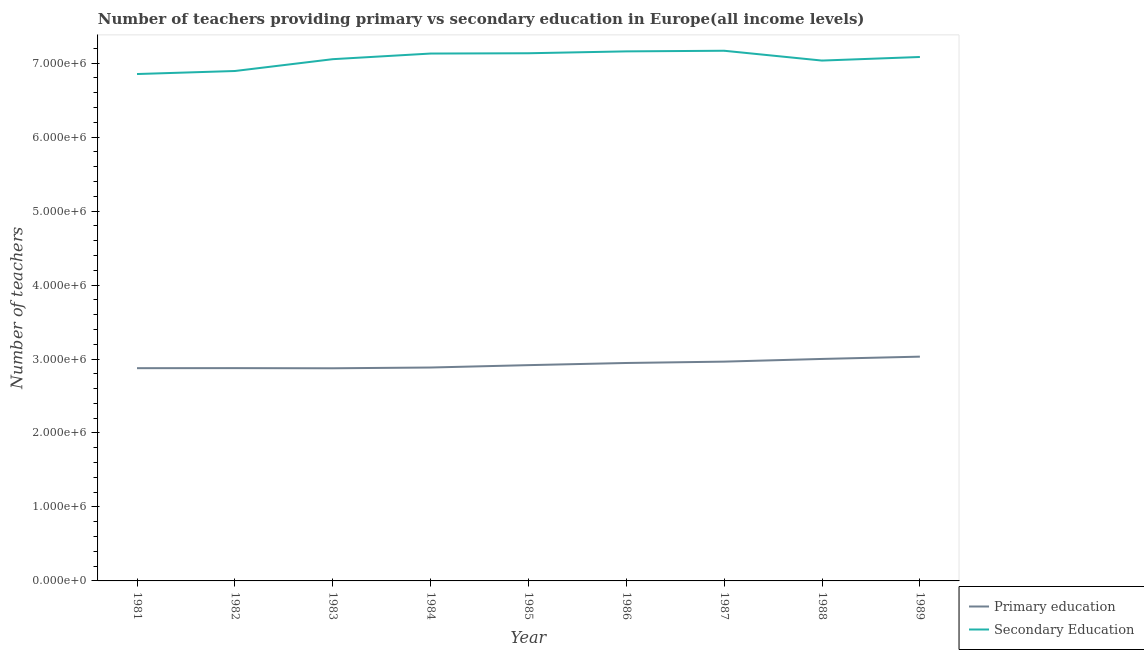What is the number of secondary teachers in 1985?
Offer a terse response. 7.13e+06. Across all years, what is the maximum number of secondary teachers?
Keep it short and to the point. 7.17e+06. Across all years, what is the minimum number of secondary teachers?
Your answer should be compact. 6.85e+06. In which year was the number of secondary teachers maximum?
Provide a short and direct response. 1987. In which year was the number of primary teachers minimum?
Offer a very short reply. 1983. What is the total number of secondary teachers in the graph?
Give a very brief answer. 6.35e+07. What is the difference between the number of secondary teachers in 1981 and that in 1986?
Make the answer very short. -3.06e+05. What is the difference between the number of secondary teachers in 1983 and the number of primary teachers in 1982?
Offer a very short reply. 4.18e+06. What is the average number of secondary teachers per year?
Your answer should be very brief. 7.06e+06. In the year 1985, what is the difference between the number of secondary teachers and number of primary teachers?
Your answer should be very brief. 4.22e+06. What is the ratio of the number of secondary teachers in 1987 to that in 1989?
Your response must be concise. 1.01. Is the number of primary teachers in 1985 less than that in 1989?
Offer a terse response. Yes. What is the difference between the highest and the second highest number of primary teachers?
Your answer should be very brief. 3.12e+04. What is the difference between the highest and the lowest number of primary teachers?
Offer a terse response. 1.57e+05. Does the number of primary teachers monotonically increase over the years?
Your response must be concise. No. Are the values on the major ticks of Y-axis written in scientific E-notation?
Your answer should be very brief. Yes. Does the graph contain any zero values?
Your answer should be very brief. No. Does the graph contain grids?
Provide a succinct answer. No. How many legend labels are there?
Your response must be concise. 2. How are the legend labels stacked?
Keep it short and to the point. Vertical. What is the title of the graph?
Your response must be concise. Number of teachers providing primary vs secondary education in Europe(all income levels). Does "Banks" appear as one of the legend labels in the graph?
Provide a short and direct response. No. What is the label or title of the X-axis?
Provide a succinct answer. Year. What is the label or title of the Y-axis?
Offer a terse response. Number of teachers. What is the Number of teachers in Primary education in 1981?
Offer a terse response. 2.88e+06. What is the Number of teachers of Secondary Education in 1981?
Your answer should be compact. 6.85e+06. What is the Number of teachers of Primary education in 1982?
Ensure brevity in your answer.  2.88e+06. What is the Number of teachers in Secondary Education in 1982?
Offer a very short reply. 6.89e+06. What is the Number of teachers of Primary education in 1983?
Your response must be concise. 2.87e+06. What is the Number of teachers in Secondary Education in 1983?
Offer a terse response. 7.05e+06. What is the Number of teachers of Primary education in 1984?
Offer a very short reply. 2.88e+06. What is the Number of teachers in Secondary Education in 1984?
Provide a succinct answer. 7.13e+06. What is the Number of teachers in Primary education in 1985?
Your answer should be very brief. 2.92e+06. What is the Number of teachers of Secondary Education in 1985?
Provide a short and direct response. 7.13e+06. What is the Number of teachers of Primary education in 1986?
Provide a short and direct response. 2.95e+06. What is the Number of teachers in Secondary Education in 1986?
Your answer should be compact. 7.16e+06. What is the Number of teachers in Primary education in 1987?
Provide a short and direct response. 2.96e+06. What is the Number of teachers in Secondary Education in 1987?
Provide a short and direct response. 7.17e+06. What is the Number of teachers of Primary education in 1988?
Provide a short and direct response. 3.00e+06. What is the Number of teachers of Secondary Education in 1988?
Give a very brief answer. 7.03e+06. What is the Number of teachers in Primary education in 1989?
Offer a terse response. 3.03e+06. What is the Number of teachers of Secondary Education in 1989?
Your answer should be compact. 7.08e+06. Across all years, what is the maximum Number of teachers of Primary education?
Offer a very short reply. 3.03e+06. Across all years, what is the maximum Number of teachers in Secondary Education?
Your answer should be very brief. 7.17e+06. Across all years, what is the minimum Number of teachers of Primary education?
Make the answer very short. 2.87e+06. Across all years, what is the minimum Number of teachers in Secondary Education?
Give a very brief answer. 6.85e+06. What is the total Number of teachers of Primary education in the graph?
Keep it short and to the point. 2.64e+07. What is the total Number of teachers of Secondary Education in the graph?
Offer a terse response. 6.35e+07. What is the difference between the Number of teachers in Primary education in 1981 and that in 1982?
Ensure brevity in your answer.  -712.75. What is the difference between the Number of teachers in Secondary Education in 1981 and that in 1982?
Your answer should be very brief. -4.10e+04. What is the difference between the Number of teachers of Primary education in 1981 and that in 1983?
Offer a terse response. 1441.75. What is the difference between the Number of teachers in Secondary Education in 1981 and that in 1983?
Keep it short and to the point. -2.01e+05. What is the difference between the Number of teachers of Primary education in 1981 and that in 1984?
Ensure brevity in your answer.  -8923. What is the difference between the Number of teachers of Secondary Education in 1981 and that in 1984?
Your answer should be compact. -2.77e+05. What is the difference between the Number of teachers in Primary education in 1981 and that in 1985?
Offer a terse response. -4.11e+04. What is the difference between the Number of teachers of Secondary Education in 1981 and that in 1985?
Provide a succinct answer. -2.81e+05. What is the difference between the Number of teachers in Primary education in 1981 and that in 1986?
Offer a terse response. -7.02e+04. What is the difference between the Number of teachers in Secondary Education in 1981 and that in 1986?
Your answer should be compact. -3.06e+05. What is the difference between the Number of teachers in Primary education in 1981 and that in 1987?
Make the answer very short. -8.87e+04. What is the difference between the Number of teachers of Secondary Education in 1981 and that in 1987?
Offer a very short reply. -3.15e+05. What is the difference between the Number of teachers of Primary education in 1981 and that in 1988?
Provide a succinct answer. -1.25e+05. What is the difference between the Number of teachers in Secondary Education in 1981 and that in 1988?
Provide a short and direct response. -1.82e+05. What is the difference between the Number of teachers of Primary education in 1981 and that in 1989?
Provide a succinct answer. -1.56e+05. What is the difference between the Number of teachers of Secondary Education in 1981 and that in 1989?
Offer a terse response. -2.31e+05. What is the difference between the Number of teachers in Primary education in 1982 and that in 1983?
Make the answer very short. 2154.5. What is the difference between the Number of teachers of Secondary Education in 1982 and that in 1983?
Give a very brief answer. -1.60e+05. What is the difference between the Number of teachers in Primary education in 1982 and that in 1984?
Offer a terse response. -8210.25. What is the difference between the Number of teachers in Secondary Education in 1982 and that in 1984?
Provide a succinct answer. -2.36e+05. What is the difference between the Number of teachers of Primary education in 1982 and that in 1985?
Your answer should be compact. -4.04e+04. What is the difference between the Number of teachers of Secondary Education in 1982 and that in 1985?
Your response must be concise. -2.40e+05. What is the difference between the Number of teachers of Primary education in 1982 and that in 1986?
Make the answer very short. -6.95e+04. What is the difference between the Number of teachers in Secondary Education in 1982 and that in 1986?
Your answer should be very brief. -2.65e+05. What is the difference between the Number of teachers in Primary education in 1982 and that in 1987?
Your response must be concise. -8.80e+04. What is the difference between the Number of teachers in Secondary Education in 1982 and that in 1987?
Your response must be concise. -2.74e+05. What is the difference between the Number of teachers in Primary education in 1982 and that in 1988?
Provide a short and direct response. -1.24e+05. What is the difference between the Number of teachers of Secondary Education in 1982 and that in 1988?
Your answer should be very brief. -1.41e+05. What is the difference between the Number of teachers of Primary education in 1982 and that in 1989?
Offer a very short reply. -1.55e+05. What is the difference between the Number of teachers in Secondary Education in 1982 and that in 1989?
Offer a terse response. -1.90e+05. What is the difference between the Number of teachers in Primary education in 1983 and that in 1984?
Give a very brief answer. -1.04e+04. What is the difference between the Number of teachers of Secondary Education in 1983 and that in 1984?
Keep it short and to the point. -7.62e+04. What is the difference between the Number of teachers of Primary education in 1983 and that in 1985?
Keep it short and to the point. -4.26e+04. What is the difference between the Number of teachers of Secondary Education in 1983 and that in 1985?
Your answer should be very brief. -8.02e+04. What is the difference between the Number of teachers in Primary education in 1983 and that in 1986?
Keep it short and to the point. -7.16e+04. What is the difference between the Number of teachers in Secondary Education in 1983 and that in 1986?
Make the answer very short. -1.06e+05. What is the difference between the Number of teachers in Primary education in 1983 and that in 1987?
Offer a terse response. -9.01e+04. What is the difference between the Number of teachers of Secondary Education in 1983 and that in 1987?
Offer a very short reply. -1.14e+05. What is the difference between the Number of teachers in Primary education in 1983 and that in 1988?
Your answer should be very brief. -1.26e+05. What is the difference between the Number of teachers in Secondary Education in 1983 and that in 1988?
Provide a short and direct response. 1.87e+04. What is the difference between the Number of teachers in Primary education in 1983 and that in 1989?
Give a very brief answer. -1.57e+05. What is the difference between the Number of teachers of Secondary Education in 1983 and that in 1989?
Give a very brief answer. -2.98e+04. What is the difference between the Number of teachers in Primary education in 1984 and that in 1985?
Provide a short and direct response. -3.22e+04. What is the difference between the Number of teachers of Secondary Education in 1984 and that in 1985?
Offer a terse response. -4047. What is the difference between the Number of teachers in Primary education in 1984 and that in 1986?
Give a very brief answer. -6.12e+04. What is the difference between the Number of teachers of Secondary Education in 1984 and that in 1986?
Your answer should be compact. -2.94e+04. What is the difference between the Number of teachers of Primary education in 1984 and that in 1987?
Your response must be concise. -7.97e+04. What is the difference between the Number of teachers of Secondary Education in 1984 and that in 1987?
Make the answer very short. -3.78e+04. What is the difference between the Number of teachers of Primary education in 1984 and that in 1988?
Your answer should be very brief. -1.16e+05. What is the difference between the Number of teachers of Secondary Education in 1984 and that in 1988?
Provide a succinct answer. 9.49e+04. What is the difference between the Number of teachers in Primary education in 1984 and that in 1989?
Provide a short and direct response. -1.47e+05. What is the difference between the Number of teachers of Secondary Education in 1984 and that in 1989?
Offer a terse response. 4.64e+04. What is the difference between the Number of teachers of Primary education in 1985 and that in 1986?
Provide a short and direct response. -2.90e+04. What is the difference between the Number of teachers of Secondary Education in 1985 and that in 1986?
Your response must be concise. -2.53e+04. What is the difference between the Number of teachers in Primary education in 1985 and that in 1987?
Keep it short and to the point. -4.75e+04. What is the difference between the Number of teachers of Secondary Education in 1985 and that in 1987?
Your answer should be compact. -3.37e+04. What is the difference between the Number of teachers of Primary education in 1985 and that in 1988?
Your answer should be very brief. -8.37e+04. What is the difference between the Number of teachers in Secondary Education in 1985 and that in 1988?
Make the answer very short. 9.90e+04. What is the difference between the Number of teachers of Primary education in 1985 and that in 1989?
Your response must be concise. -1.15e+05. What is the difference between the Number of teachers in Secondary Education in 1985 and that in 1989?
Offer a terse response. 5.04e+04. What is the difference between the Number of teachers in Primary education in 1986 and that in 1987?
Ensure brevity in your answer.  -1.85e+04. What is the difference between the Number of teachers of Secondary Education in 1986 and that in 1987?
Make the answer very short. -8406.5. What is the difference between the Number of teachers of Primary education in 1986 and that in 1988?
Ensure brevity in your answer.  -5.47e+04. What is the difference between the Number of teachers of Secondary Education in 1986 and that in 1988?
Your answer should be very brief. 1.24e+05. What is the difference between the Number of teachers of Primary education in 1986 and that in 1989?
Keep it short and to the point. -8.58e+04. What is the difference between the Number of teachers in Secondary Education in 1986 and that in 1989?
Offer a very short reply. 7.58e+04. What is the difference between the Number of teachers in Primary education in 1987 and that in 1988?
Your response must be concise. -3.62e+04. What is the difference between the Number of teachers of Secondary Education in 1987 and that in 1988?
Your answer should be compact. 1.33e+05. What is the difference between the Number of teachers in Primary education in 1987 and that in 1989?
Provide a succinct answer. -6.73e+04. What is the difference between the Number of teachers of Secondary Education in 1987 and that in 1989?
Give a very brief answer. 8.42e+04. What is the difference between the Number of teachers in Primary education in 1988 and that in 1989?
Your answer should be very brief. -3.12e+04. What is the difference between the Number of teachers of Secondary Education in 1988 and that in 1989?
Your answer should be very brief. -4.85e+04. What is the difference between the Number of teachers of Primary education in 1981 and the Number of teachers of Secondary Education in 1982?
Offer a very short reply. -4.02e+06. What is the difference between the Number of teachers of Primary education in 1981 and the Number of teachers of Secondary Education in 1983?
Provide a succinct answer. -4.18e+06. What is the difference between the Number of teachers in Primary education in 1981 and the Number of teachers in Secondary Education in 1984?
Your answer should be compact. -4.25e+06. What is the difference between the Number of teachers in Primary education in 1981 and the Number of teachers in Secondary Education in 1985?
Offer a terse response. -4.26e+06. What is the difference between the Number of teachers in Primary education in 1981 and the Number of teachers in Secondary Education in 1986?
Offer a very short reply. -4.28e+06. What is the difference between the Number of teachers in Primary education in 1981 and the Number of teachers in Secondary Education in 1987?
Your answer should be very brief. -4.29e+06. What is the difference between the Number of teachers in Primary education in 1981 and the Number of teachers in Secondary Education in 1988?
Offer a very short reply. -4.16e+06. What is the difference between the Number of teachers in Primary education in 1981 and the Number of teachers in Secondary Education in 1989?
Provide a short and direct response. -4.21e+06. What is the difference between the Number of teachers in Primary education in 1982 and the Number of teachers in Secondary Education in 1983?
Give a very brief answer. -4.18e+06. What is the difference between the Number of teachers of Primary education in 1982 and the Number of teachers of Secondary Education in 1984?
Offer a very short reply. -4.25e+06. What is the difference between the Number of teachers of Primary education in 1982 and the Number of teachers of Secondary Education in 1985?
Provide a succinct answer. -4.26e+06. What is the difference between the Number of teachers in Primary education in 1982 and the Number of teachers in Secondary Education in 1986?
Make the answer very short. -4.28e+06. What is the difference between the Number of teachers of Primary education in 1982 and the Number of teachers of Secondary Education in 1987?
Provide a succinct answer. -4.29e+06. What is the difference between the Number of teachers in Primary education in 1982 and the Number of teachers in Secondary Education in 1988?
Your answer should be compact. -4.16e+06. What is the difference between the Number of teachers in Primary education in 1982 and the Number of teachers in Secondary Education in 1989?
Your answer should be compact. -4.21e+06. What is the difference between the Number of teachers in Primary education in 1983 and the Number of teachers in Secondary Education in 1984?
Offer a very short reply. -4.25e+06. What is the difference between the Number of teachers in Primary education in 1983 and the Number of teachers in Secondary Education in 1985?
Offer a terse response. -4.26e+06. What is the difference between the Number of teachers of Primary education in 1983 and the Number of teachers of Secondary Education in 1986?
Offer a very short reply. -4.28e+06. What is the difference between the Number of teachers in Primary education in 1983 and the Number of teachers in Secondary Education in 1987?
Offer a terse response. -4.29e+06. What is the difference between the Number of teachers of Primary education in 1983 and the Number of teachers of Secondary Education in 1988?
Ensure brevity in your answer.  -4.16e+06. What is the difference between the Number of teachers of Primary education in 1983 and the Number of teachers of Secondary Education in 1989?
Give a very brief answer. -4.21e+06. What is the difference between the Number of teachers in Primary education in 1984 and the Number of teachers in Secondary Education in 1985?
Keep it short and to the point. -4.25e+06. What is the difference between the Number of teachers in Primary education in 1984 and the Number of teachers in Secondary Education in 1986?
Ensure brevity in your answer.  -4.27e+06. What is the difference between the Number of teachers in Primary education in 1984 and the Number of teachers in Secondary Education in 1987?
Offer a terse response. -4.28e+06. What is the difference between the Number of teachers of Primary education in 1984 and the Number of teachers of Secondary Education in 1988?
Your answer should be compact. -4.15e+06. What is the difference between the Number of teachers of Primary education in 1984 and the Number of teachers of Secondary Education in 1989?
Make the answer very short. -4.20e+06. What is the difference between the Number of teachers in Primary education in 1985 and the Number of teachers in Secondary Education in 1986?
Make the answer very short. -4.24e+06. What is the difference between the Number of teachers in Primary education in 1985 and the Number of teachers in Secondary Education in 1987?
Your response must be concise. -4.25e+06. What is the difference between the Number of teachers of Primary education in 1985 and the Number of teachers of Secondary Education in 1988?
Give a very brief answer. -4.12e+06. What is the difference between the Number of teachers in Primary education in 1985 and the Number of teachers in Secondary Education in 1989?
Your answer should be compact. -4.17e+06. What is the difference between the Number of teachers in Primary education in 1986 and the Number of teachers in Secondary Education in 1987?
Your response must be concise. -4.22e+06. What is the difference between the Number of teachers in Primary education in 1986 and the Number of teachers in Secondary Education in 1988?
Keep it short and to the point. -4.09e+06. What is the difference between the Number of teachers in Primary education in 1986 and the Number of teachers in Secondary Education in 1989?
Offer a very short reply. -4.14e+06. What is the difference between the Number of teachers of Primary education in 1987 and the Number of teachers of Secondary Education in 1988?
Offer a terse response. -4.07e+06. What is the difference between the Number of teachers of Primary education in 1987 and the Number of teachers of Secondary Education in 1989?
Ensure brevity in your answer.  -4.12e+06. What is the difference between the Number of teachers in Primary education in 1988 and the Number of teachers in Secondary Education in 1989?
Make the answer very short. -4.08e+06. What is the average Number of teachers of Primary education per year?
Ensure brevity in your answer.  2.93e+06. What is the average Number of teachers in Secondary Education per year?
Make the answer very short. 7.06e+06. In the year 1981, what is the difference between the Number of teachers of Primary education and Number of teachers of Secondary Education?
Keep it short and to the point. -3.98e+06. In the year 1982, what is the difference between the Number of teachers of Primary education and Number of teachers of Secondary Education?
Keep it short and to the point. -4.02e+06. In the year 1983, what is the difference between the Number of teachers in Primary education and Number of teachers in Secondary Education?
Ensure brevity in your answer.  -4.18e+06. In the year 1984, what is the difference between the Number of teachers of Primary education and Number of teachers of Secondary Education?
Offer a very short reply. -4.24e+06. In the year 1985, what is the difference between the Number of teachers of Primary education and Number of teachers of Secondary Education?
Provide a succinct answer. -4.22e+06. In the year 1986, what is the difference between the Number of teachers in Primary education and Number of teachers in Secondary Education?
Offer a terse response. -4.21e+06. In the year 1987, what is the difference between the Number of teachers of Primary education and Number of teachers of Secondary Education?
Give a very brief answer. -4.20e+06. In the year 1988, what is the difference between the Number of teachers in Primary education and Number of teachers in Secondary Education?
Give a very brief answer. -4.03e+06. In the year 1989, what is the difference between the Number of teachers in Primary education and Number of teachers in Secondary Education?
Provide a succinct answer. -4.05e+06. What is the ratio of the Number of teachers in Secondary Education in 1981 to that in 1982?
Give a very brief answer. 0.99. What is the ratio of the Number of teachers in Secondary Education in 1981 to that in 1983?
Offer a very short reply. 0.97. What is the ratio of the Number of teachers in Primary education in 1981 to that in 1984?
Your response must be concise. 1. What is the ratio of the Number of teachers in Secondary Education in 1981 to that in 1984?
Ensure brevity in your answer.  0.96. What is the ratio of the Number of teachers of Primary education in 1981 to that in 1985?
Make the answer very short. 0.99. What is the ratio of the Number of teachers of Secondary Education in 1981 to that in 1985?
Ensure brevity in your answer.  0.96. What is the ratio of the Number of teachers of Primary education in 1981 to that in 1986?
Offer a terse response. 0.98. What is the ratio of the Number of teachers in Secondary Education in 1981 to that in 1986?
Offer a very short reply. 0.96. What is the ratio of the Number of teachers of Primary education in 1981 to that in 1987?
Your response must be concise. 0.97. What is the ratio of the Number of teachers of Secondary Education in 1981 to that in 1987?
Give a very brief answer. 0.96. What is the ratio of the Number of teachers in Primary education in 1981 to that in 1988?
Your answer should be compact. 0.96. What is the ratio of the Number of teachers in Secondary Education in 1981 to that in 1988?
Offer a terse response. 0.97. What is the ratio of the Number of teachers of Primary education in 1981 to that in 1989?
Your answer should be very brief. 0.95. What is the ratio of the Number of teachers in Secondary Education in 1981 to that in 1989?
Your answer should be very brief. 0.97. What is the ratio of the Number of teachers in Secondary Education in 1982 to that in 1983?
Offer a terse response. 0.98. What is the ratio of the Number of teachers in Secondary Education in 1982 to that in 1984?
Your response must be concise. 0.97. What is the ratio of the Number of teachers in Primary education in 1982 to that in 1985?
Ensure brevity in your answer.  0.99. What is the ratio of the Number of teachers in Secondary Education in 1982 to that in 1985?
Make the answer very short. 0.97. What is the ratio of the Number of teachers of Primary education in 1982 to that in 1986?
Offer a very short reply. 0.98. What is the ratio of the Number of teachers of Secondary Education in 1982 to that in 1986?
Make the answer very short. 0.96. What is the ratio of the Number of teachers of Primary education in 1982 to that in 1987?
Keep it short and to the point. 0.97. What is the ratio of the Number of teachers in Secondary Education in 1982 to that in 1987?
Keep it short and to the point. 0.96. What is the ratio of the Number of teachers of Primary education in 1982 to that in 1988?
Ensure brevity in your answer.  0.96. What is the ratio of the Number of teachers in Secondary Education in 1982 to that in 1988?
Ensure brevity in your answer.  0.98. What is the ratio of the Number of teachers in Primary education in 1982 to that in 1989?
Offer a very short reply. 0.95. What is the ratio of the Number of teachers of Secondary Education in 1982 to that in 1989?
Make the answer very short. 0.97. What is the ratio of the Number of teachers in Secondary Education in 1983 to that in 1984?
Provide a succinct answer. 0.99. What is the ratio of the Number of teachers of Primary education in 1983 to that in 1985?
Provide a short and direct response. 0.99. What is the ratio of the Number of teachers in Secondary Education in 1983 to that in 1985?
Provide a succinct answer. 0.99. What is the ratio of the Number of teachers in Primary education in 1983 to that in 1986?
Ensure brevity in your answer.  0.98. What is the ratio of the Number of teachers of Secondary Education in 1983 to that in 1986?
Your response must be concise. 0.99. What is the ratio of the Number of teachers of Primary education in 1983 to that in 1987?
Offer a very short reply. 0.97. What is the ratio of the Number of teachers in Secondary Education in 1983 to that in 1987?
Make the answer very short. 0.98. What is the ratio of the Number of teachers in Primary education in 1983 to that in 1988?
Offer a very short reply. 0.96. What is the ratio of the Number of teachers of Primary education in 1983 to that in 1989?
Give a very brief answer. 0.95. What is the ratio of the Number of teachers of Secondary Education in 1983 to that in 1989?
Your answer should be compact. 1. What is the ratio of the Number of teachers in Secondary Education in 1984 to that in 1985?
Give a very brief answer. 1. What is the ratio of the Number of teachers of Primary education in 1984 to that in 1986?
Offer a very short reply. 0.98. What is the ratio of the Number of teachers of Secondary Education in 1984 to that in 1986?
Ensure brevity in your answer.  1. What is the ratio of the Number of teachers in Primary education in 1984 to that in 1987?
Your response must be concise. 0.97. What is the ratio of the Number of teachers of Primary education in 1984 to that in 1988?
Offer a terse response. 0.96. What is the ratio of the Number of teachers of Secondary Education in 1984 to that in 1988?
Offer a terse response. 1.01. What is the ratio of the Number of teachers of Primary education in 1984 to that in 1989?
Your response must be concise. 0.95. What is the ratio of the Number of teachers in Secondary Education in 1984 to that in 1989?
Provide a short and direct response. 1.01. What is the ratio of the Number of teachers in Secondary Education in 1985 to that in 1986?
Ensure brevity in your answer.  1. What is the ratio of the Number of teachers in Secondary Education in 1985 to that in 1987?
Your answer should be very brief. 1. What is the ratio of the Number of teachers in Primary education in 1985 to that in 1988?
Your response must be concise. 0.97. What is the ratio of the Number of teachers of Secondary Education in 1985 to that in 1988?
Keep it short and to the point. 1.01. What is the ratio of the Number of teachers in Primary education in 1985 to that in 1989?
Offer a very short reply. 0.96. What is the ratio of the Number of teachers of Secondary Education in 1985 to that in 1989?
Provide a short and direct response. 1.01. What is the ratio of the Number of teachers of Secondary Education in 1986 to that in 1987?
Ensure brevity in your answer.  1. What is the ratio of the Number of teachers in Primary education in 1986 to that in 1988?
Offer a very short reply. 0.98. What is the ratio of the Number of teachers in Secondary Education in 1986 to that in 1988?
Provide a succinct answer. 1.02. What is the ratio of the Number of teachers of Primary education in 1986 to that in 1989?
Your response must be concise. 0.97. What is the ratio of the Number of teachers of Secondary Education in 1986 to that in 1989?
Provide a short and direct response. 1.01. What is the ratio of the Number of teachers of Primary education in 1987 to that in 1988?
Ensure brevity in your answer.  0.99. What is the ratio of the Number of teachers of Secondary Education in 1987 to that in 1988?
Provide a succinct answer. 1.02. What is the ratio of the Number of teachers of Primary education in 1987 to that in 1989?
Your answer should be compact. 0.98. What is the ratio of the Number of teachers in Secondary Education in 1987 to that in 1989?
Make the answer very short. 1.01. What is the difference between the highest and the second highest Number of teachers in Primary education?
Your answer should be very brief. 3.12e+04. What is the difference between the highest and the second highest Number of teachers of Secondary Education?
Your response must be concise. 8406.5. What is the difference between the highest and the lowest Number of teachers of Primary education?
Offer a terse response. 1.57e+05. What is the difference between the highest and the lowest Number of teachers of Secondary Education?
Offer a very short reply. 3.15e+05. 